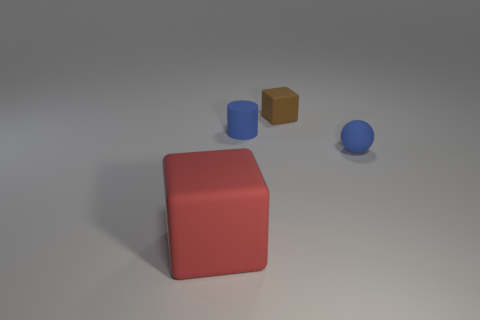There is a brown thing; is it the same shape as the small blue matte object that is in front of the blue cylinder?
Your response must be concise. No. Is the number of big objects to the right of the red cube greater than the number of big red rubber blocks in front of the small blue matte sphere?
Give a very brief answer. No. Is there anything else of the same color as the tiny matte sphere?
Your answer should be compact. Yes. There is a matte cube behind the cube that is in front of the brown rubber cube; are there any small brown rubber objects that are in front of it?
Make the answer very short. No. Does the small blue object that is right of the blue cylinder have the same shape as the red rubber object?
Your answer should be very brief. No. Is the number of small brown cubes on the left side of the red thing less than the number of rubber balls that are in front of the small blue ball?
Provide a succinct answer. No. What material is the small cube?
Ensure brevity in your answer.  Rubber. Is the color of the big cube the same as the cube behind the blue sphere?
Your response must be concise. No. How many rubber blocks are left of the small cube?
Offer a terse response. 1. Are there fewer brown rubber blocks that are right of the blue ball than large green rubber blocks?
Provide a short and direct response. No. 